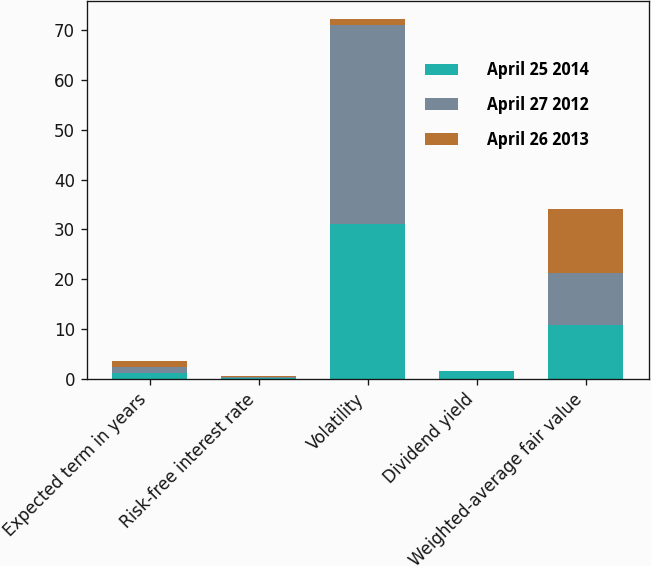Convert chart. <chart><loc_0><loc_0><loc_500><loc_500><stacked_bar_chart><ecel><fcel>Expected term in years<fcel>Risk-free interest rate<fcel>Volatility<fcel>Dividend yield<fcel>Weighted-average fair value<nl><fcel>April 25 2014<fcel>1.2<fcel>0.2<fcel>31<fcel>1.6<fcel>10.83<nl><fcel>April 27 2012<fcel>1.2<fcel>0.2<fcel>40<fcel>0<fcel>10.36<nl><fcel>April 26 2013<fcel>1.2<fcel>0.2<fcel>1.2<fcel>0<fcel>12.87<nl></chart> 